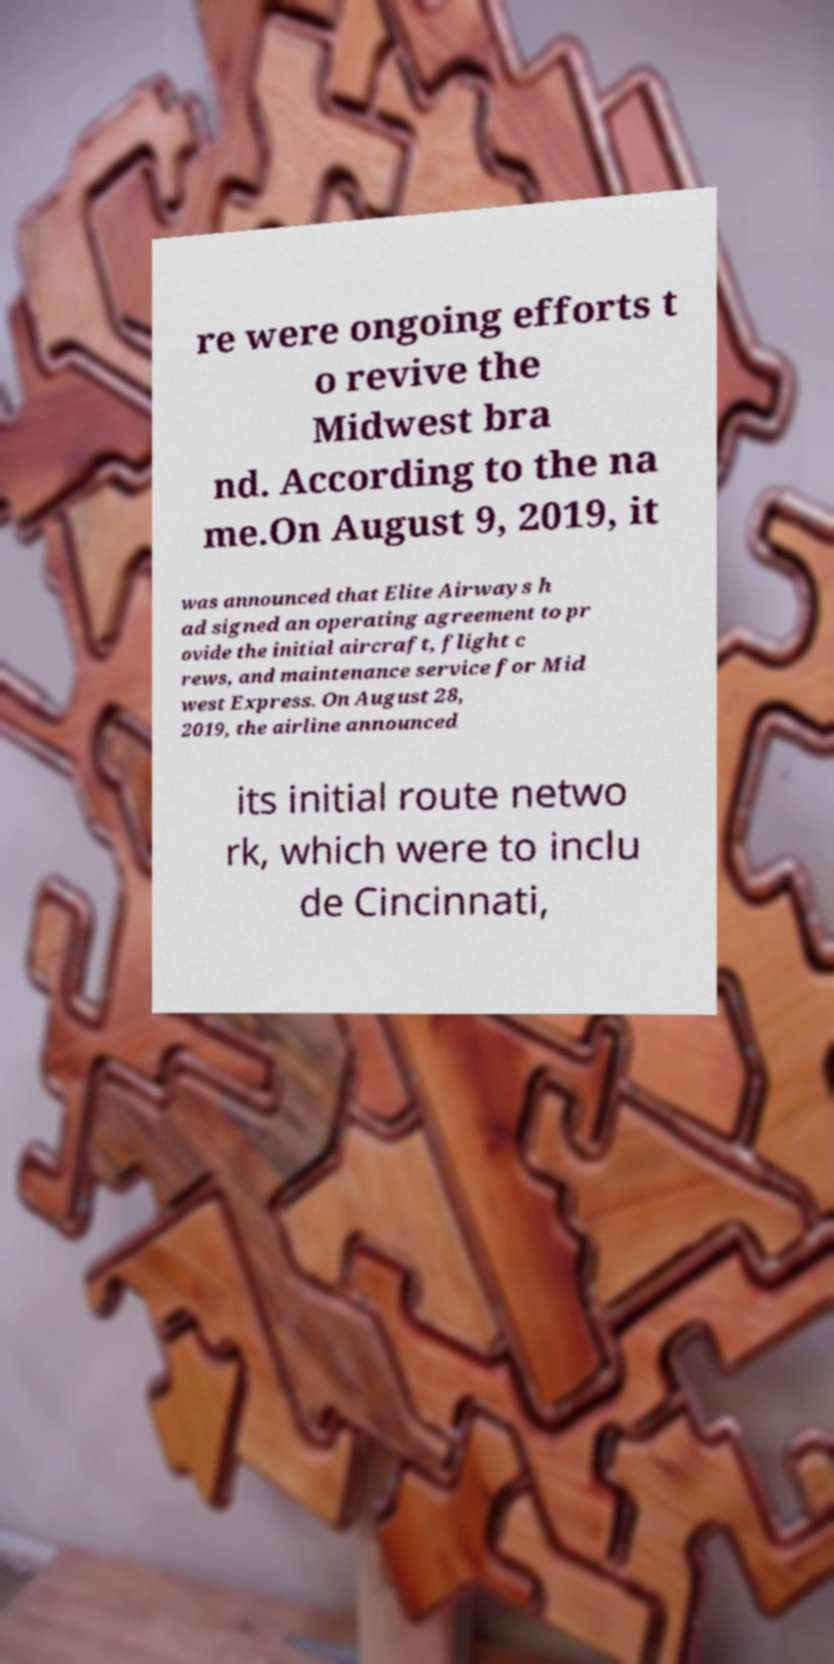Please identify and transcribe the text found in this image. re were ongoing efforts t o revive the Midwest bra nd. According to the na me.On August 9, 2019, it was announced that Elite Airways h ad signed an operating agreement to pr ovide the initial aircraft, flight c rews, and maintenance service for Mid west Express. On August 28, 2019, the airline announced its initial route netwo rk, which were to inclu de Cincinnati, 